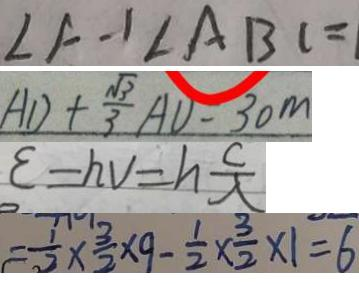Convert formula to latex. <formula><loc_0><loc_0><loc_500><loc_500>\angle A - 1 \angle A B C = 
 A D + \frac { \sqrt { 3 } } { 3 } A D = 3 0 m 
 \varepsilon = h v = h \frac { c } { \lambda } 
 = \frac { 1 } { 2 } \times \frac { 3 } { 2 } \times 9 - \frac { 1 } { 2 } \times \frac { 3 } { 2 } \times 1 = 6</formula> 